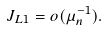Convert formula to latex. <formula><loc_0><loc_0><loc_500><loc_500>J _ { L 1 } = o ( \mu _ { n } ^ { - 1 } ) .</formula> 